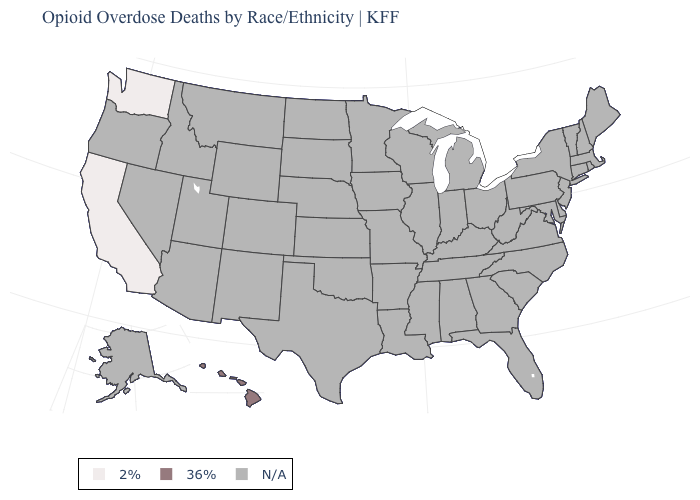What is the value of New Hampshire?
Concise answer only. N/A. Name the states that have a value in the range 2%?
Keep it brief. California, Washington. Name the states that have a value in the range 36%?
Give a very brief answer. Hawaii. What is the value of South Dakota?
Write a very short answer. N/A. Name the states that have a value in the range 2%?
Keep it brief. California, Washington. What is the highest value in the USA?
Quick response, please. 36%. Is the legend a continuous bar?
Give a very brief answer. No. Does Washington have the lowest value in the USA?
Answer briefly. Yes. Name the states that have a value in the range 2%?
Keep it brief. California, Washington. Does Hawaii have the lowest value in the West?
Write a very short answer. No. 